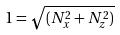<formula> <loc_0><loc_0><loc_500><loc_500>1 = \sqrt { ( N _ { x } ^ { 2 } + N _ { z } ^ { 2 } ) }</formula> 